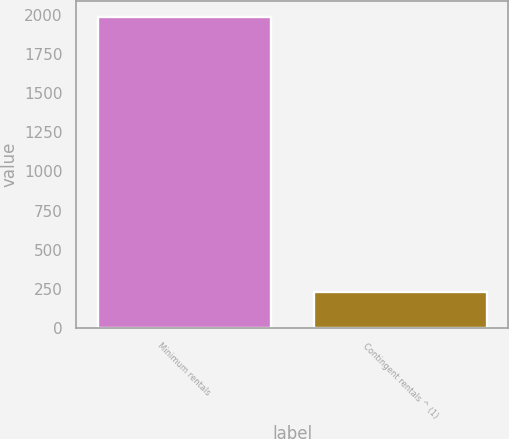Convert chart to OTSL. <chart><loc_0><loc_0><loc_500><loc_500><bar_chart><fcel>Minimum rentals<fcel>Contingent rentals ^ (1)<nl><fcel>1990<fcel>228<nl></chart> 